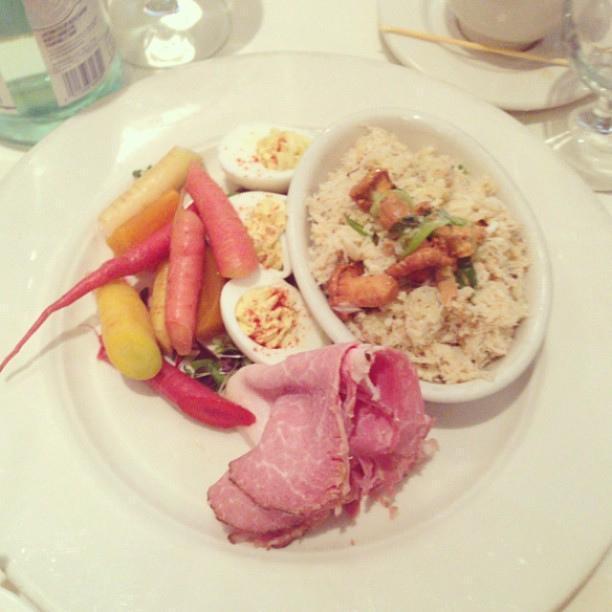How many dining tables can you see?
Give a very brief answer. 1. How many carrots are in the photo?
Give a very brief answer. 5. How many orange cones are there?
Give a very brief answer. 0. 